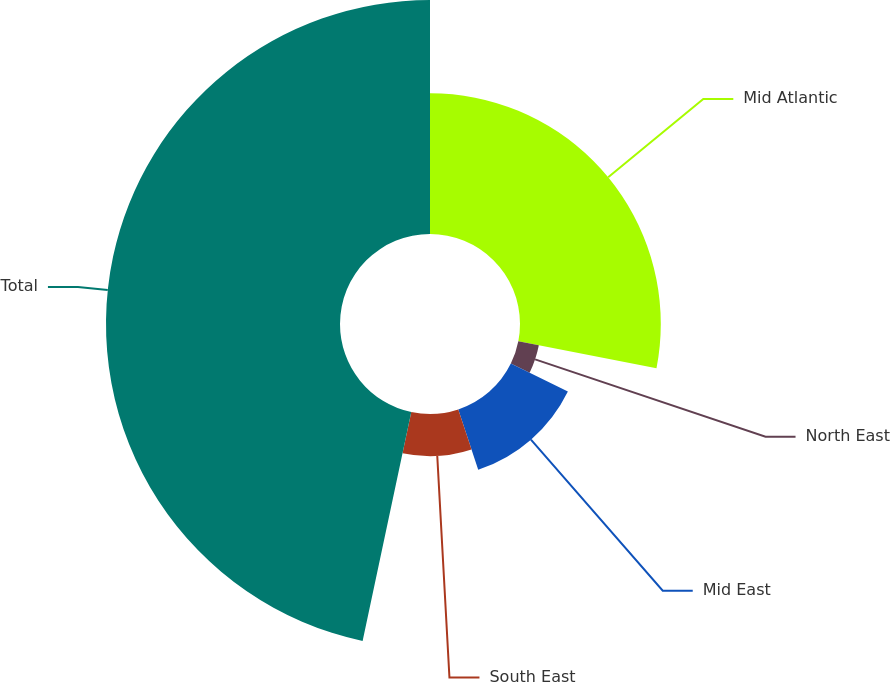<chart> <loc_0><loc_0><loc_500><loc_500><pie_chart><fcel>Mid Atlantic<fcel>North East<fcel>Mid East<fcel>South East<fcel>Total<nl><fcel>28.08%<fcel>4.17%<fcel>12.67%<fcel>8.42%<fcel>46.67%<nl></chart> 